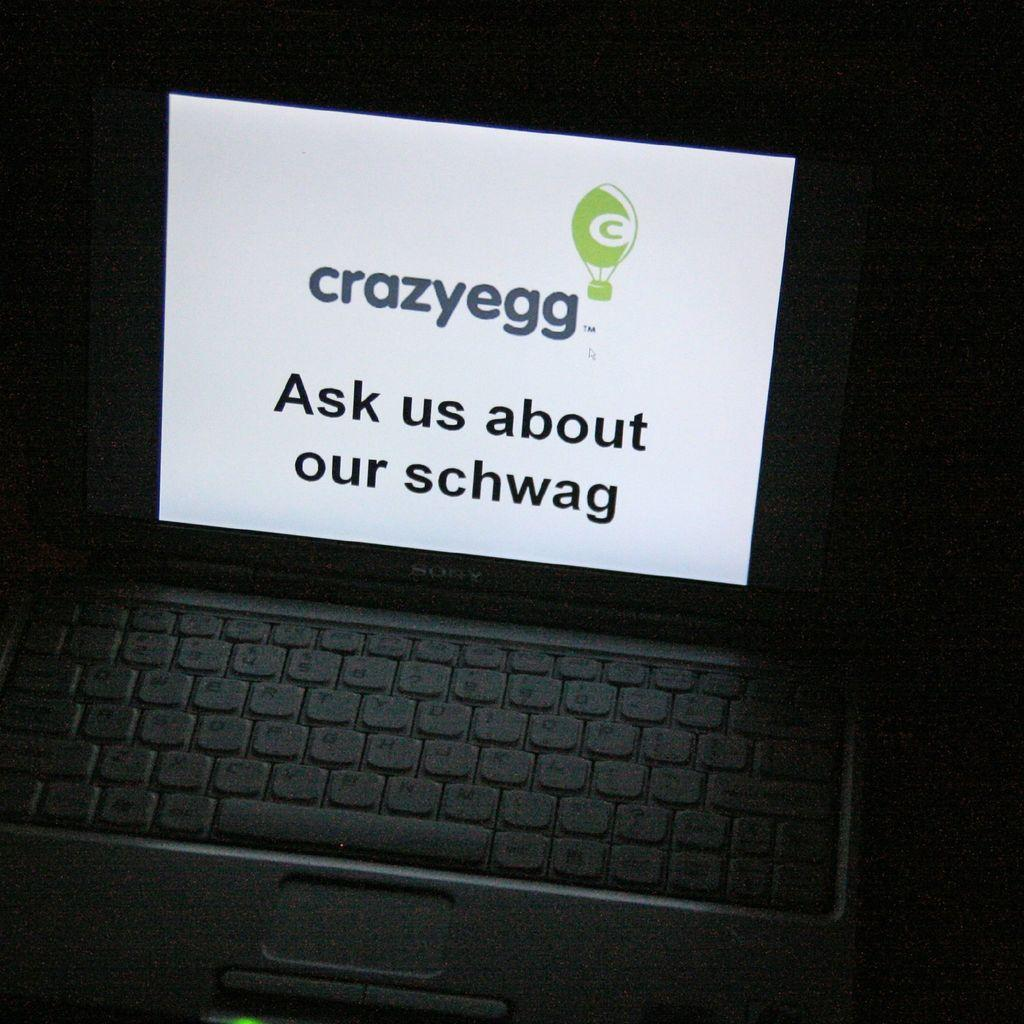<image>
Relay a brief, clear account of the picture shown. Sony laptop with a screen that says "Ask us about our schwag". 